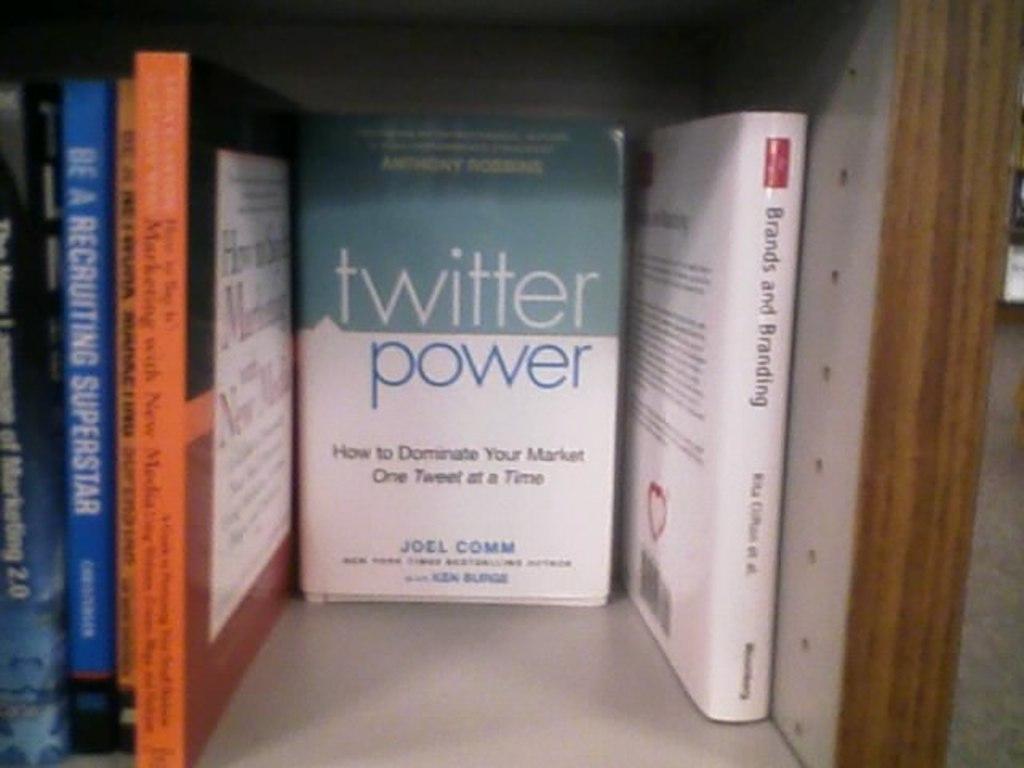Of what social media is this book about?
Give a very brief answer. Twitter. Who wrote twitter power?
Offer a very short reply. Joel comm. 